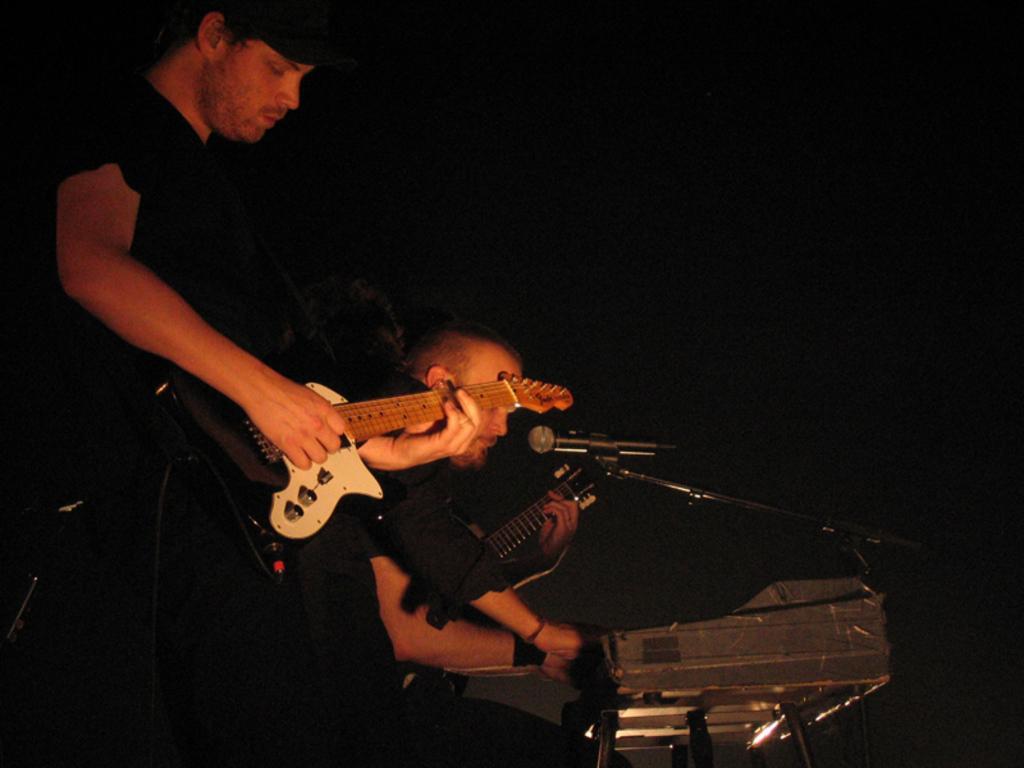Could you give a brief overview of what you see in this image? This picture shows a man holding a guitar and playing it. He is wearing a cap. Beside him, there is another man playing a Piano and Guitar here. There is a microphone in front of these musical instruments. 